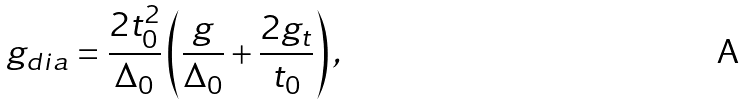Convert formula to latex. <formula><loc_0><loc_0><loc_500><loc_500>g _ { d i a } = \frac { 2 t _ { 0 } ^ { 2 } } { \Delta _ { 0 } } \left ( \frac { g } { \Delta _ { 0 } } + \frac { 2 g _ { t } } { t _ { 0 } } \right ) ,</formula> 